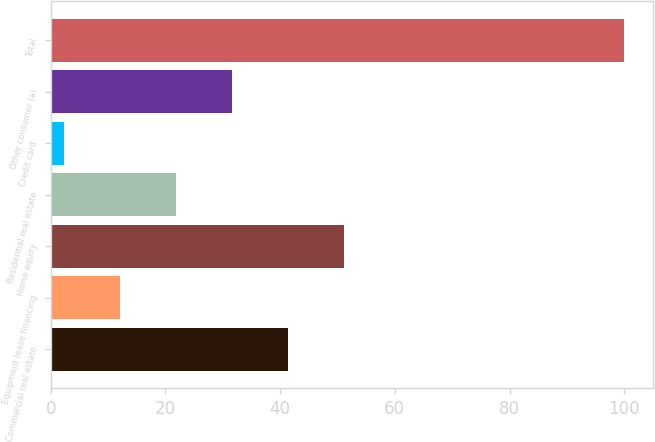<chart> <loc_0><loc_0><loc_500><loc_500><bar_chart><fcel>Commercial real estate<fcel>Equipment lease financing<fcel>Home equity<fcel>Residential real estate<fcel>Credit card<fcel>Other consumer (a)<fcel>Total<nl><fcel>41.38<fcel>12.07<fcel>51.15<fcel>21.84<fcel>2.3<fcel>31.61<fcel>100<nl></chart> 